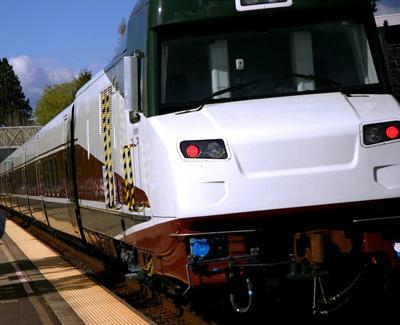Describe the objects in this image and their specific colors. I can see a train in black, gray, lavender, darkgray, and maroon tones in this image. 